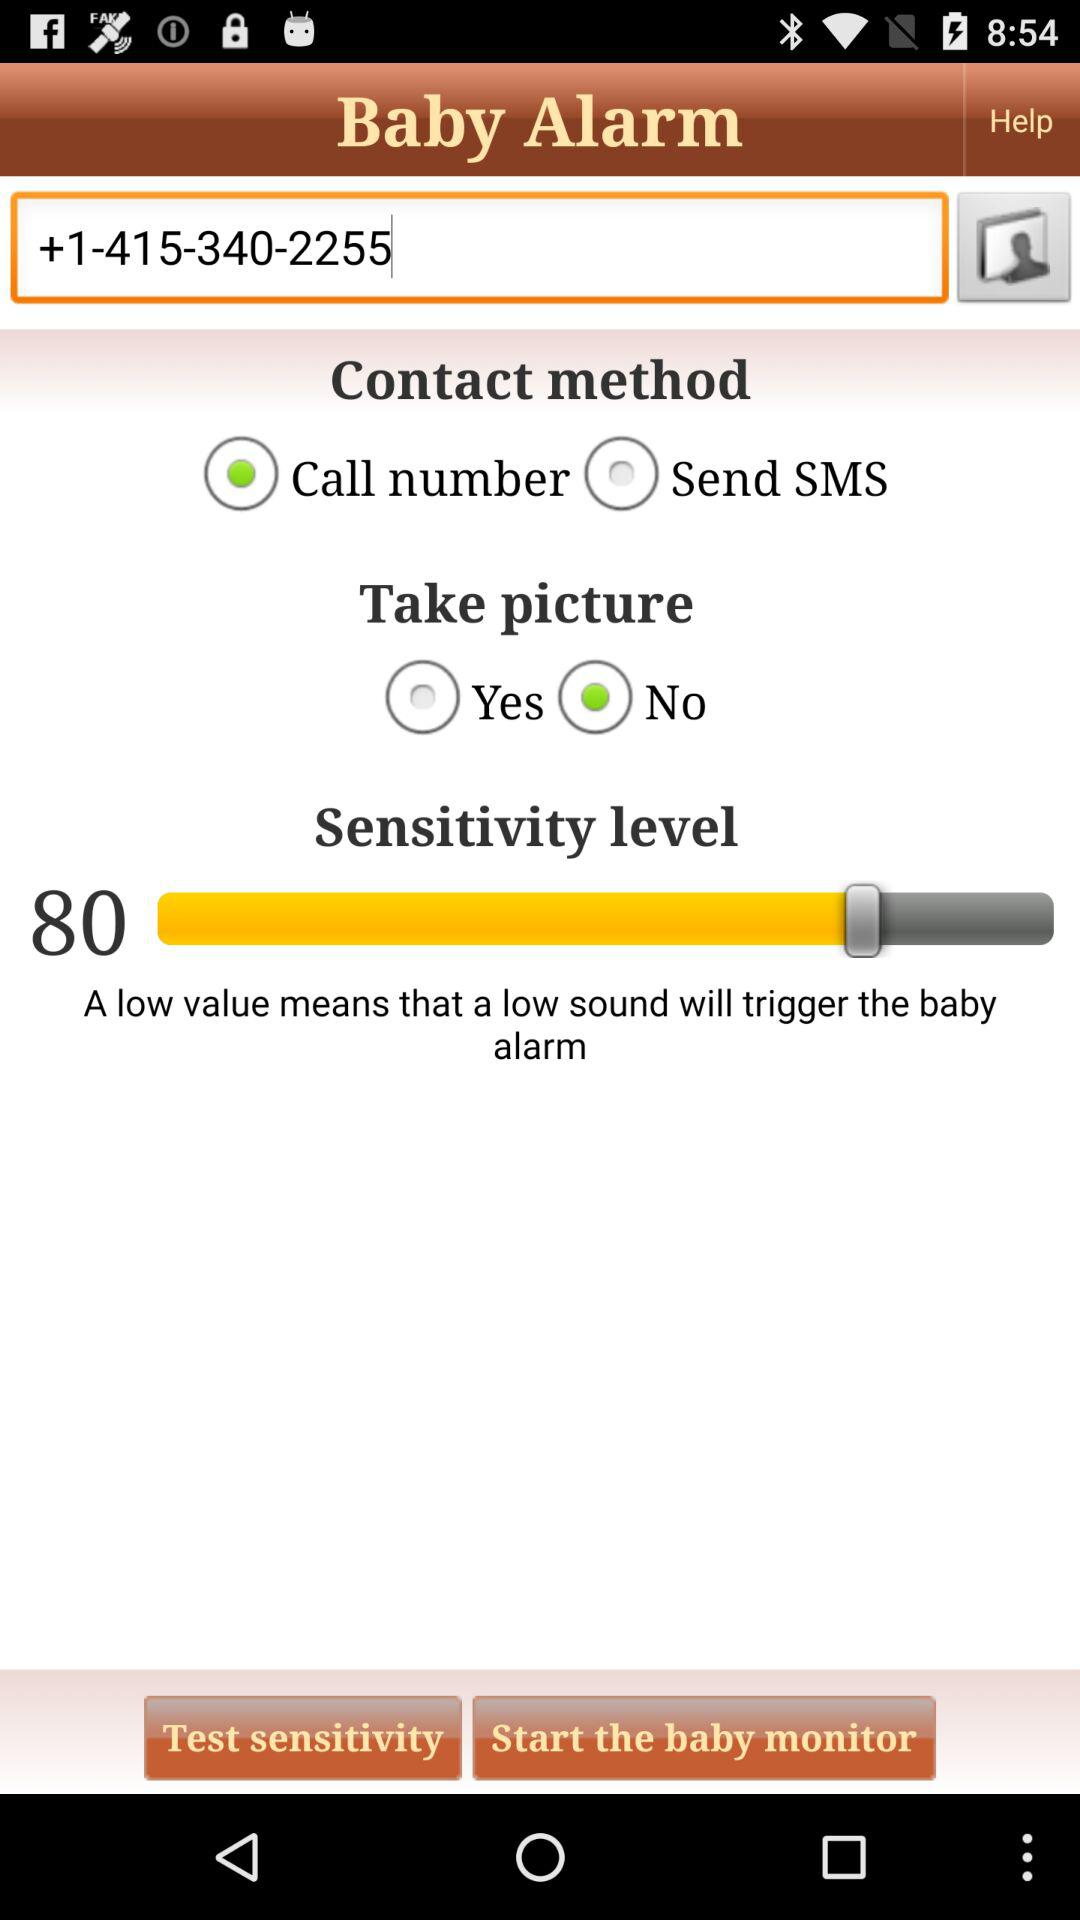For how long will the baby alarm be active?
When the provided information is insufficient, respond with <no answer>. <no answer> 